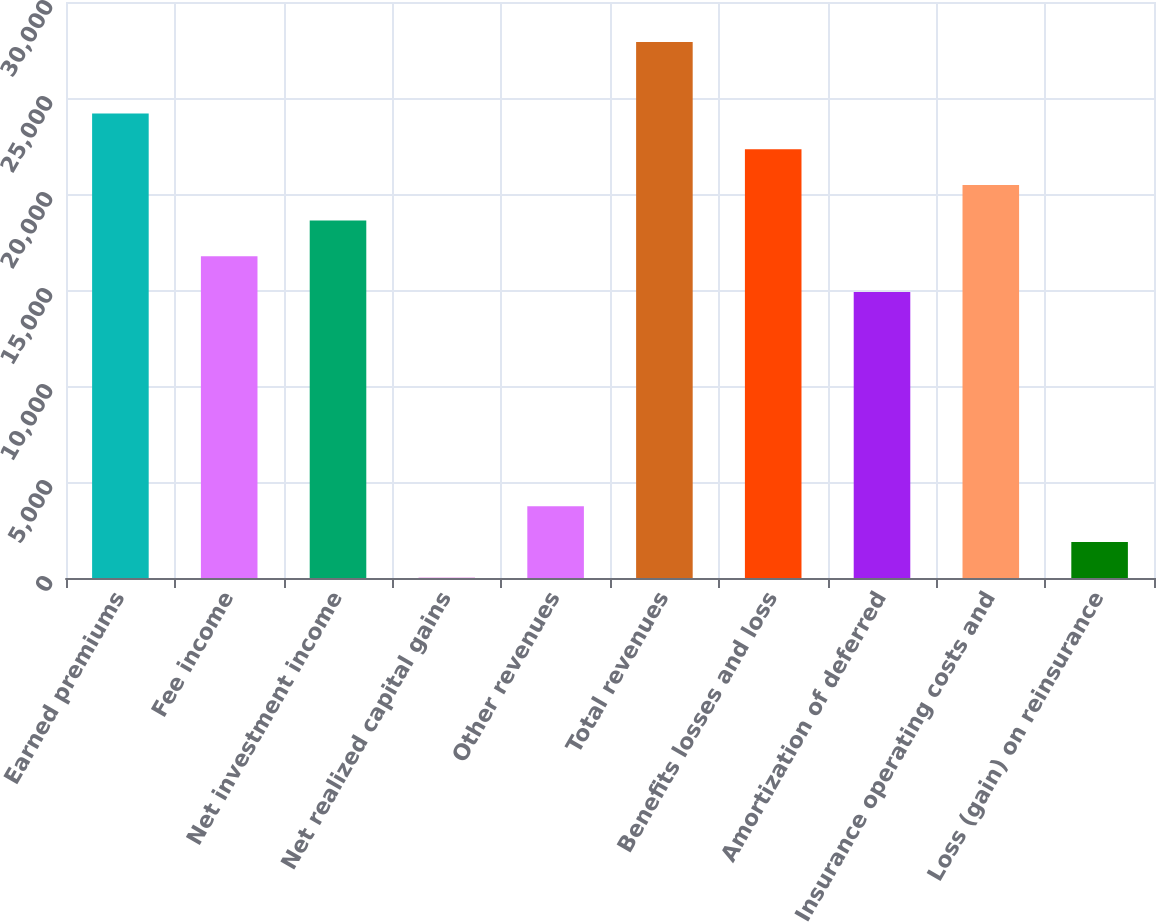<chart> <loc_0><loc_0><loc_500><loc_500><bar_chart><fcel>Earned premiums<fcel>Fee income<fcel>Net investment income<fcel>Net realized capital gains<fcel>Other revenues<fcel>Total revenues<fcel>Benefits losses and loss<fcel>Amortization of deferred<fcel>Insurance operating costs and<fcel>Loss (gain) on reinsurance<nl><fcel>24193.4<fcel>16754.2<fcel>18614<fcel>16<fcel>3735.6<fcel>27913<fcel>22333.6<fcel>14894.4<fcel>20473.8<fcel>1875.8<nl></chart> 